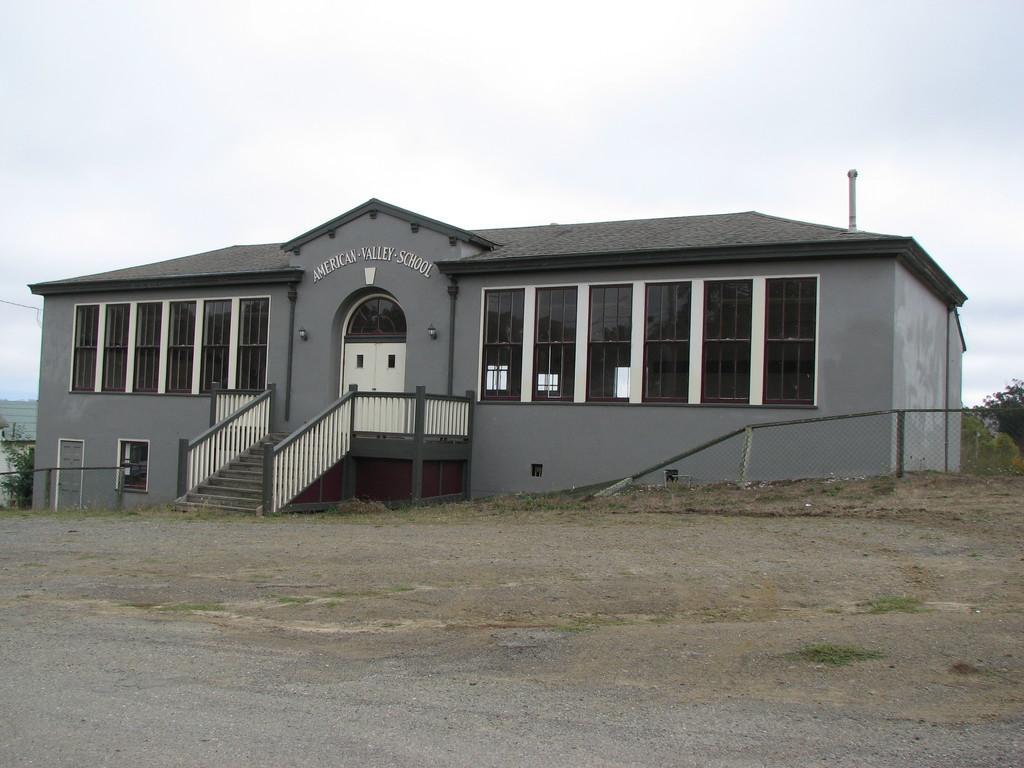Describe this image in one or two sentences. In this image we can see a building, steps, fence, pole and other objects. In the background of the image there are trees and other objects. At the top of the image there is the sky. At the bottom of the image there is the ground. 